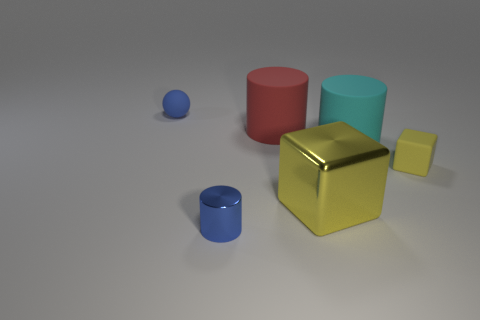Do the shiny thing right of the tiny metallic cylinder and the small block have the same color?
Your answer should be very brief. Yes. What number of objects are either big brown rubber blocks or matte things to the left of the metal cylinder?
Give a very brief answer. 1. What material is the thing that is in front of the tiny sphere and behind the big cyan rubber cylinder?
Your answer should be very brief. Rubber. There is a blue object that is on the left side of the metallic cylinder; what material is it?
Provide a short and direct response. Rubber. What color is the block that is the same material as the big red thing?
Make the answer very short. Yellow. Does the big yellow object have the same shape as the thing to the right of the cyan cylinder?
Provide a succinct answer. Yes. Are there any large objects behind the small sphere?
Your response must be concise. No. What is the material of the big object that is the same color as the tiny rubber block?
Your response must be concise. Metal. Do the cyan rubber cylinder and the red cylinder on the left side of the large yellow block have the same size?
Give a very brief answer. Yes. Are there any other blocks of the same color as the small block?
Ensure brevity in your answer.  Yes. 